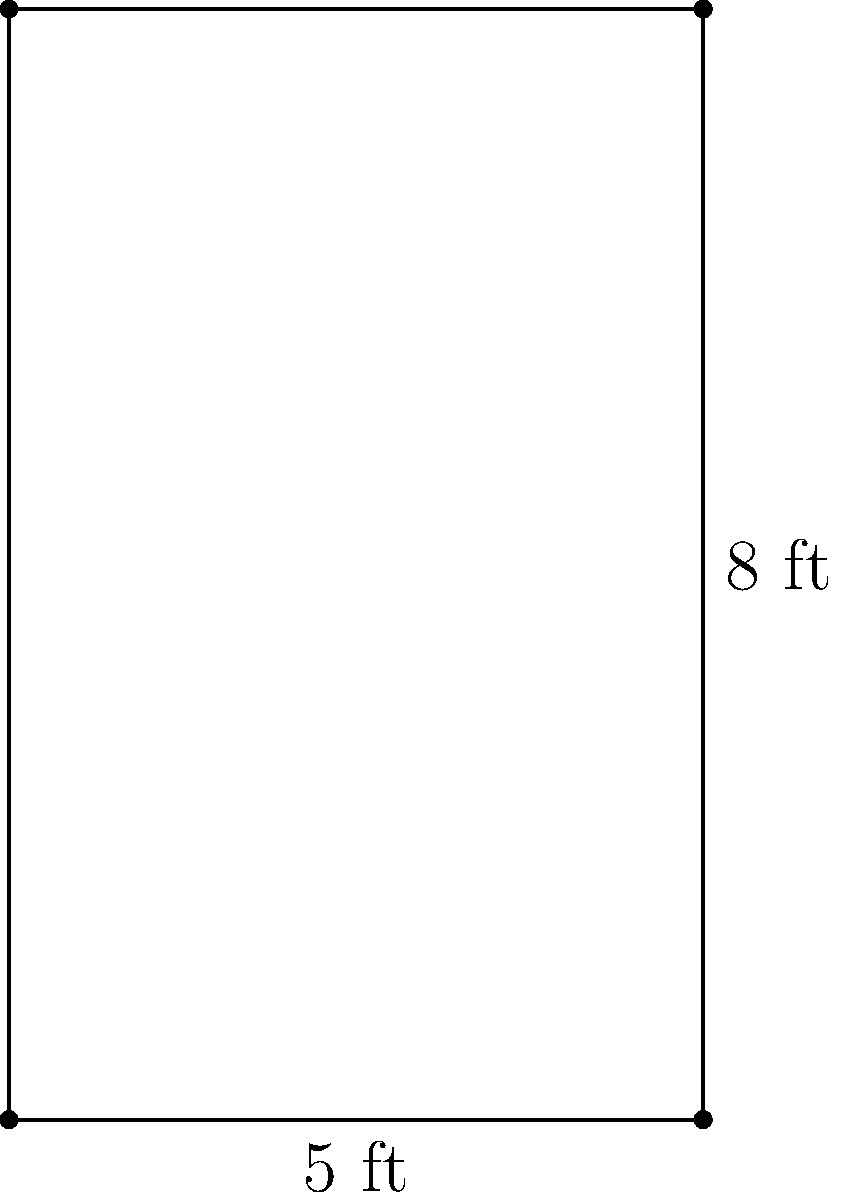As a microbiologist, you need to calculate the surface area of a new rectangular lab bench for proper disinfection protocols. The bench measures 8 feet in length and 5 feet in width. What is the total surface area of the lab bench in square feet? To calculate the surface area of the rectangular lab bench, we need to use the formula for the area of a rectangle:

$$A = l \times w$$

Where:
$A$ = area
$l$ = length
$w$ = width

Given:
Length ($l$) = 8 feet
Width ($w$) = 5 feet

Step 1: Substitute the values into the formula
$$A = 8 \text{ ft} \times 5 \text{ ft}$$

Step 2: Multiply the length and width
$$A = 40 \text{ ft}^2$$

Therefore, the total surface area of the lab bench is 40 square feet.
Answer: 40 ft² 